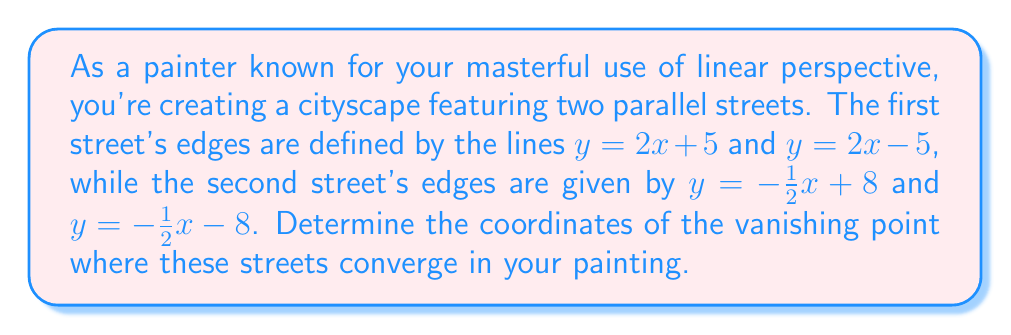Could you help me with this problem? To find the vanishing point, we need to determine where the parallel lines of each street intersect. This point of intersection is the vanishing point in linear perspective.

1. For the first street, we have two parallel lines:
   $y = 2x + 5$ and $y = 2x - 5$

2. For the second street, we have two more parallel lines:
   $y = -\frac{1}{2}x + 8$ and $y = -\frac{1}{2}x - 8$

3. To find the vanishing point, we need to find the intersection of any line from the first street with any line from the second street. Let's choose $y = 2x + 5$ and $y = -\frac{1}{2}x + 8$.

4. At the point of intersection, the y-coordinates will be equal:
   $2x + 5 = -\frac{1}{2}x + 8$

5. Solve this equation for x:
   $2x + 5 = -\frac{1}{2}x + 8$
   $2x + \frac{1}{2}x = 8 - 5$
   $\frac{5}{2}x = 3$
   $x = \frac{6}{5} = 1.2$

6. Now that we have the x-coordinate, we can find the y-coordinate by substituting x into either of the original equations. Let's use $y = 2x + 5$:
   $y = 2(1.2) + 5 = 2.4 + 5 = 7.4$

Therefore, the vanishing point is at the coordinates (1.2, 7.4).
Answer: The coordinates of the vanishing point are (1.2, 7.4). 